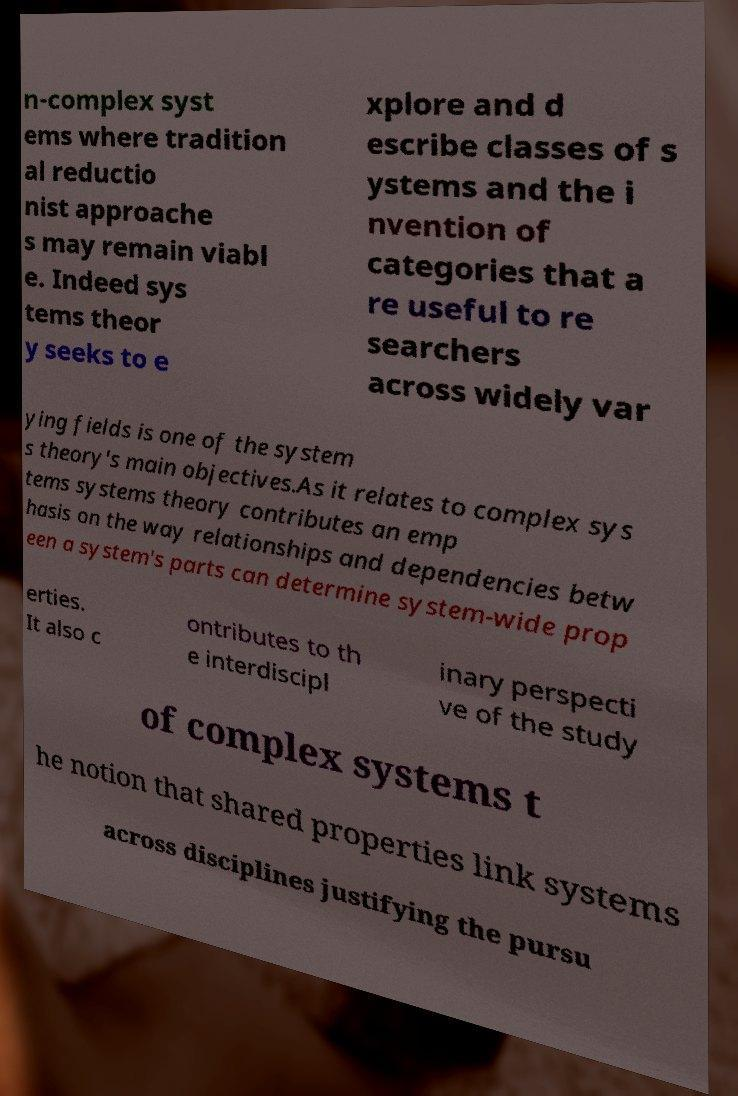I need the written content from this picture converted into text. Can you do that? n-complex syst ems where tradition al reductio nist approache s may remain viabl e. Indeed sys tems theor y seeks to e xplore and d escribe classes of s ystems and the i nvention of categories that a re useful to re searchers across widely var ying fields is one of the system s theory's main objectives.As it relates to complex sys tems systems theory contributes an emp hasis on the way relationships and dependencies betw een a system's parts can determine system-wide prop erties. It also c ontributes to th e interdiscipl inary perspecti ve of the study of complex systems t he notion that shared properties link systems across disciplines justifying the pursu 